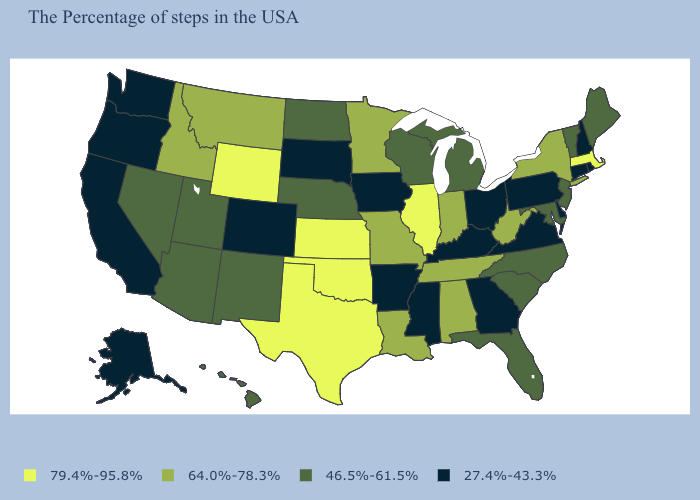What is the value of Kansas?
Keep it brief. 79.4%-95.8%. Name the states that have a value in the range 64.0%-78.3%?
Quick response, please. New York, West Virginia, Indiana, Alabama, Tennessee, Louisiana, Missouri, Minnesota, Montana, Idaho. What is the value of North Dakota?
Concise answer only. 46.5%-61.5%. What is the value of Florida?
Quick response, please. 46.5%-61.5%. Name the states that have a value in the range 46.5%-61.5%?
Quick response, please. Maine, Vermont, New Jersey, Maryland, North Carolina, South Carolina, Florida, Michigan, Wisconsin, Nebraska, North Dakota, New Mexico, Utah, Arizona, Nevada, Hawaii. Which states have the highest value in the USA?
Answer briefly. Massachusetts, Illinois, Kansas, Oklahoma, Texas, Wyoming. How many symbols are there in the legend?
Be succinct. 4. Among the states that border New York , which have the lowest value?
Quick response, please. Connecticut, Pennsylvania. Among the states that border Wisconsin , does Illinois have the highest value?
Write a very short answer. Yes. Name the states that have a value in the range 46.5%-61.5%?
Answer briefly. Maine, Vermont, New Jersey, Maryland, North Carolina, South Carolina, Florida, Michigan, Wisconsin, Nebraska, North Dakota, New Mexico, Utah, Arizona, Nevada, Hawaii. Does Connecticut have the highest value in the Northeast?
Answer briefly. No. Name the states that have a value in the range 27.4%-43.3%?
Be succinct. Rhode Island, New Hampshire, Connecticut, Delaware, Pennsylvania, Virginia, Ohio, Georgia, Kentucky, Mississippi, Arkansas, Iowa, South Dakota, Colorado, California, Washington, Oregon, Alaska. Which states hav the highest value in the South?
Quick response, please. Oklahoma, Texas. What is the highest value in the USA?
Concise answer only. 79.4%-95.8%. Does North Carolina have the same value as Montana?
Quick response, please. No. 